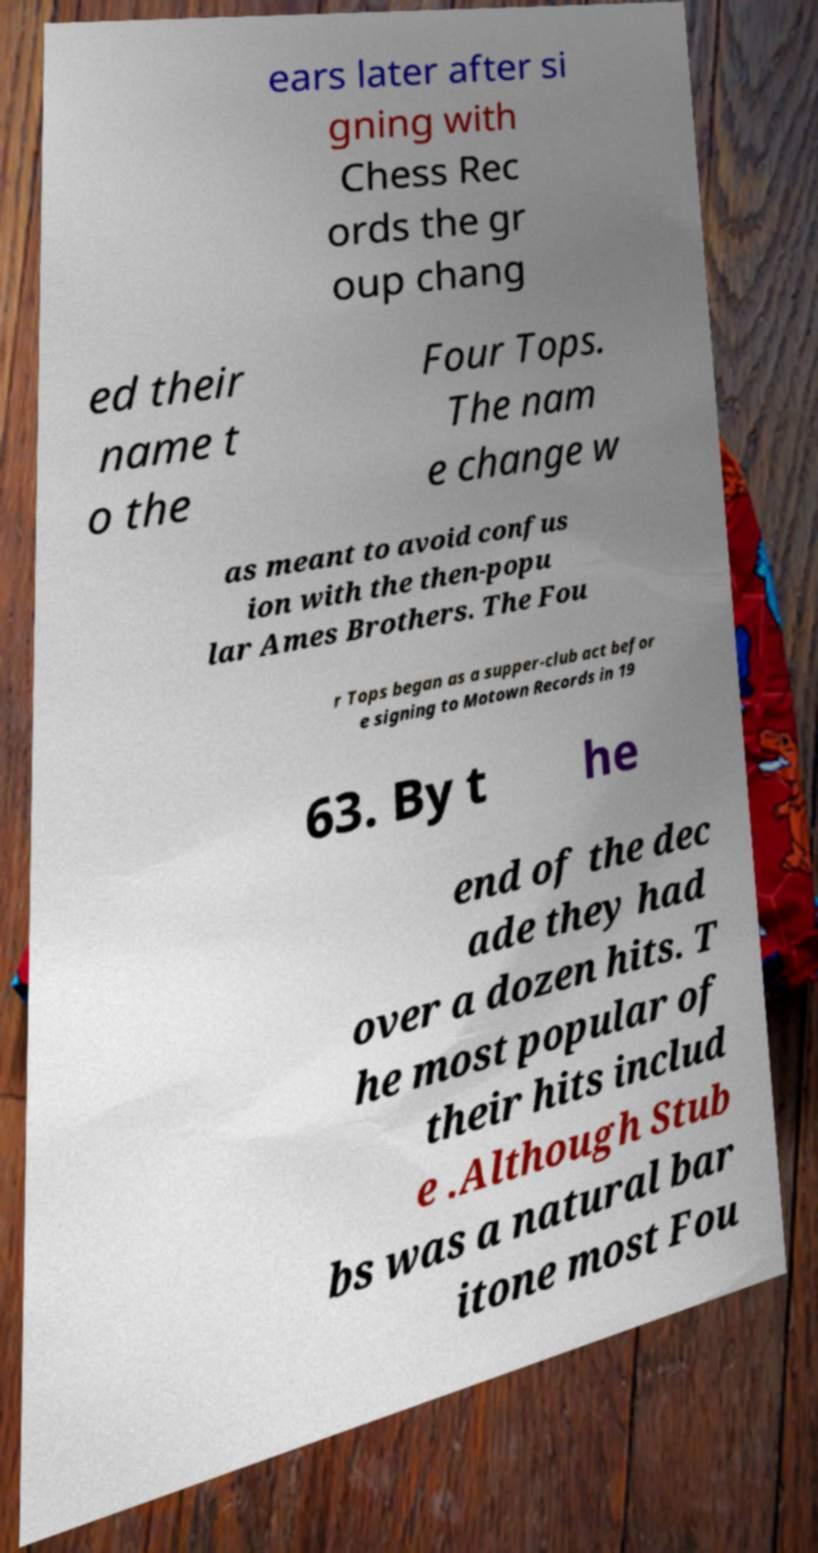I need the written content from this picture converted into text. Can you do that? ears later after si gning with Chess Rec ords the gr oup chang ed their name t o the Four Tops. The nam e change w as meant to avoid confus ion with the then-popu lar Ames Brothers. The Fou r Tops began as a supper-club act befor e signing to Motown Records in 19 63. By t he end of the dec ade they had over a dozen hits. T he most popular of their hits includ e .Although Stub bs was a natural bar itone most Fou 